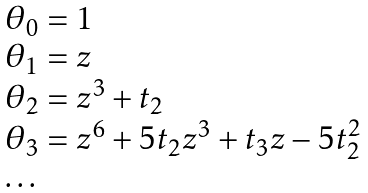Convert formula to latex. <formula><loc_0><loc_0><loc_500><loc_500>\begin{array} { l } \theta _ { 0 } = 1 \\ \theta _ { 1 } = z \\ \theta _ { 2 } = z ^ { 3 } + t _ { 2 } \\ \theta _ { 3 } = z ^ { 6 } + 5 t _ { 2 } z ^ { 3 } + t _ { 3 } z - 5 t _ { 2 } ^ { 2 } \\ \dots \end{array}</formula> 